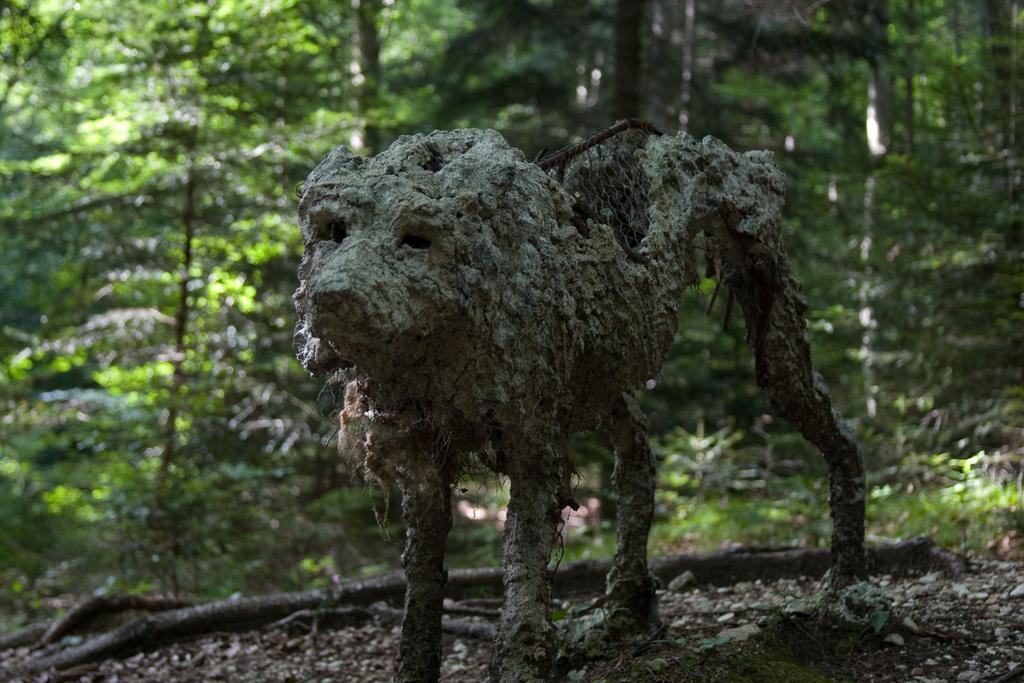Can you describe this image briefly? In this picture we can observe a shape of an animal on the land. In the background there are some trees and plants on the ground. 